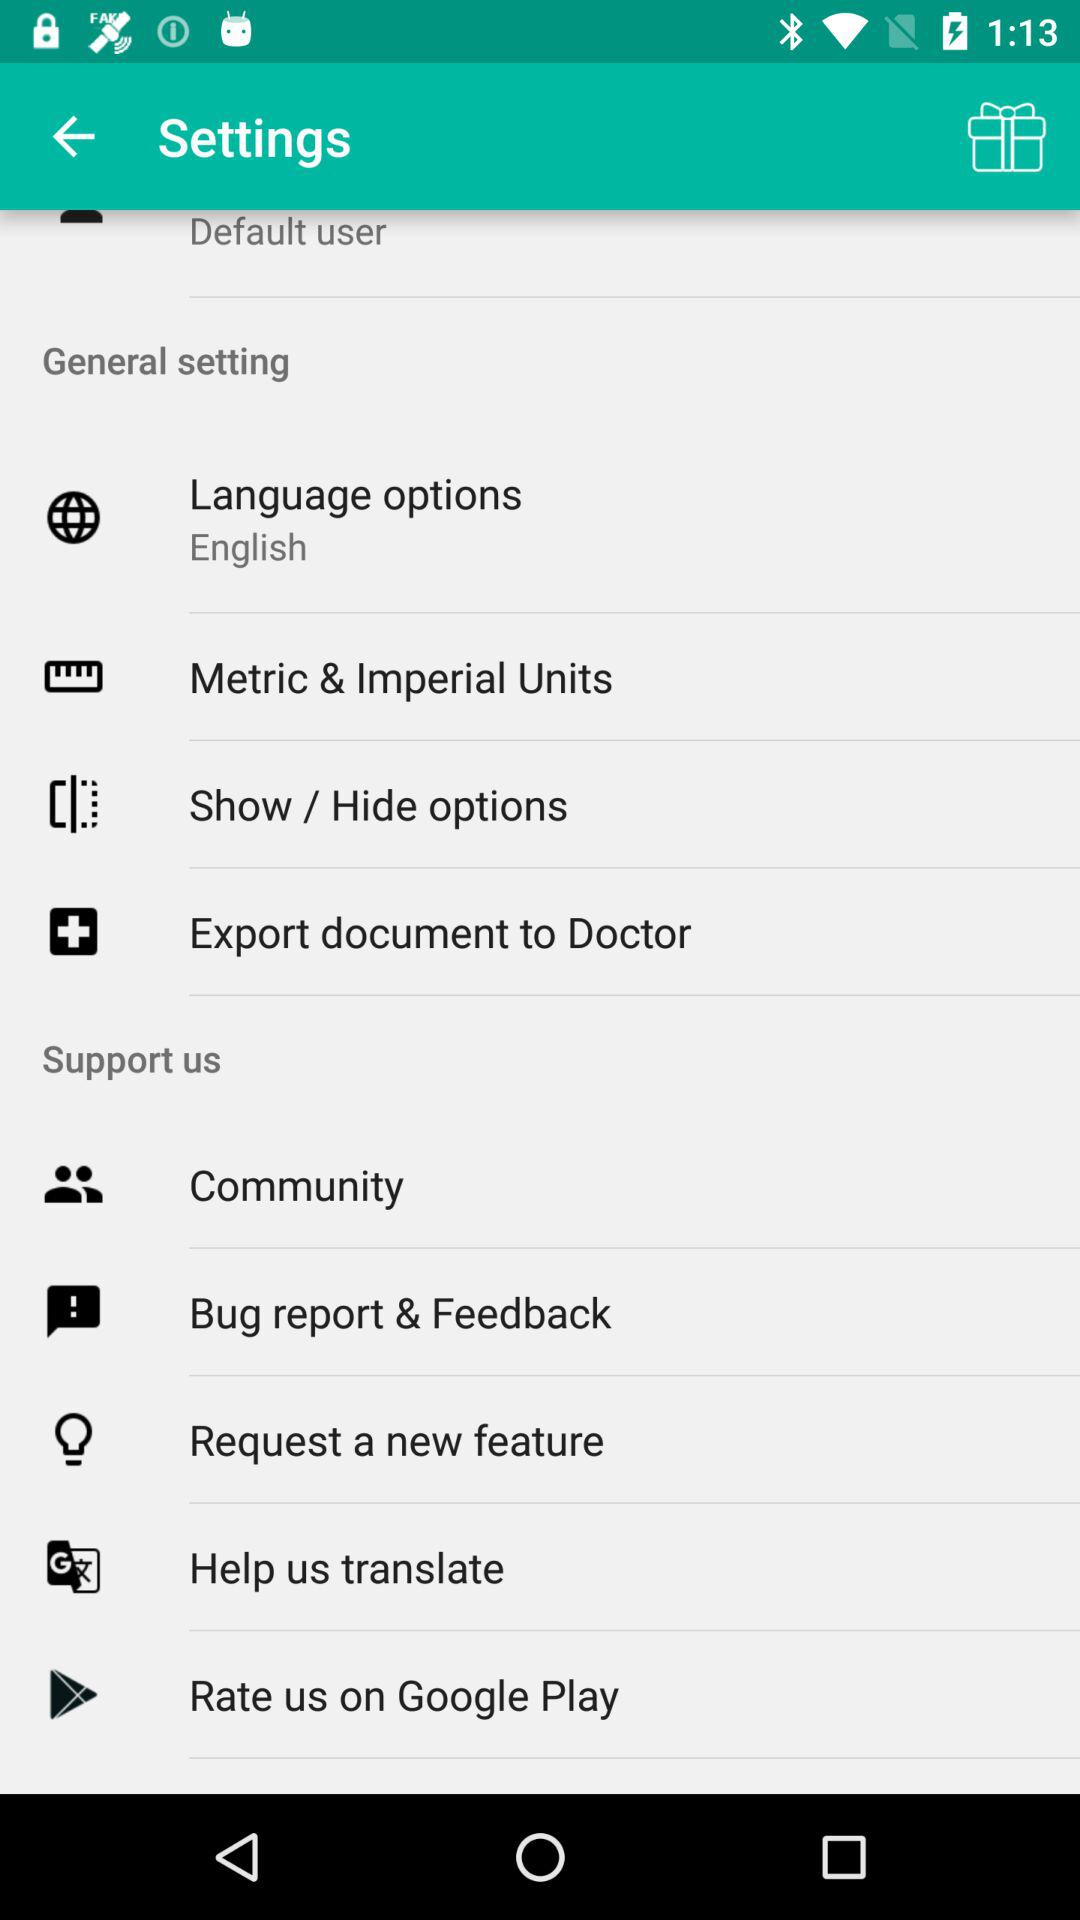What is the opted language? The opted language is English. 